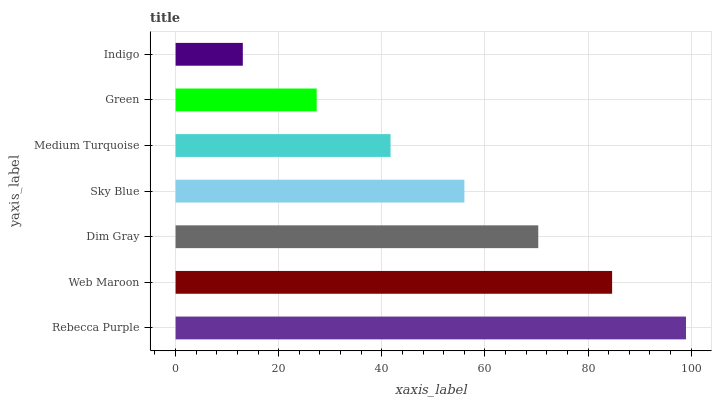Is Indigo the minimum?
Answer yes or no. Yes. Is Rebecca Purple the maximum?
Answer yes or no. Yes. Is Web Maroon the minimum?
Answer yes or no. No. Is Web Maroon the maximum?
Answer yes or no. No. Is Rebecca Purple greater than Web Maroon?
Answer yes or no. Yes. Is Web Maroon less than Rebecca Purple?
Answer yes or no. Yes. Is Web Maroon greater than Rebecca Purple?
Answer yes or no. No. Is Rebecca Purple less than Web Maroon?
Answer yes or no. No. Is Sky Blue the high median?
Answer yes or no. Yes. Is Sky Blue the low median?
Answer yes or no. Yes. Is Indigo the high median?
Answer yes or no. No. Is Dim Gray the low median?
Answer yes or no. No. 